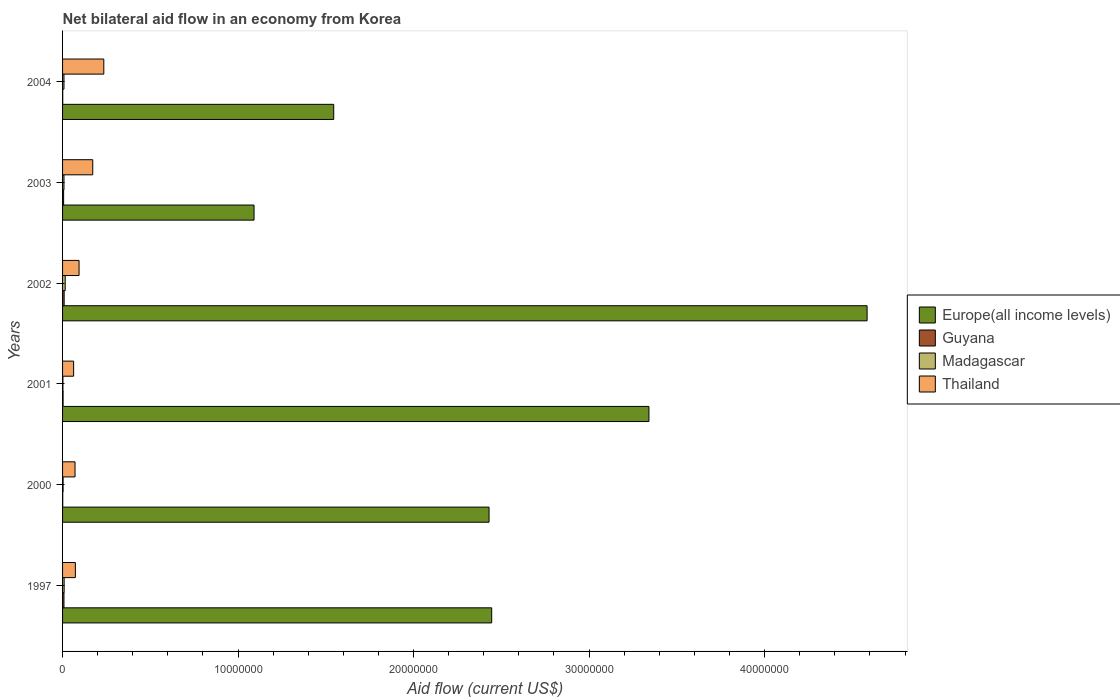How many bars are there on the 4th tick from the bottom?
Give a very brief answer. 4. Across all years, what is the maximum net bilateral aid flow in Europe(all income levels)?
Offer a terse response. 4.58e+07. Across all years, what is the minimum net bilateral aid flow in Guyana?
Your response must be concise. 10000. In which year was the net bilateral aid flow in Madagascar minimum?
Make the answer very short. 2001. What is the difference between the net bilateral aid flow in Guyana in 2003 and the net bilateral aid flow in Europe(all income levels) in 2002?
Your response must be concise. -4.58e+07. What is the average net bilateral aid flow in Madagascar per year?
Your answer should be compact. 7.50e+04. In the year 2000, what is the difference between the net bilateral aid flow in Guyana and net bilateral aid flow in Europe(all income levels)?
Make the answer very short. -2.43e+07. Is the net bilateral aid flow in Europe(all income levels) in 2000 less than that in 2004?
Make the answer very short. No. Is the difference between the net bilateral aid flow in Guyana in 2002 and 2003 greater than the difference between the net bilateral aid flow in Europe(all income levels) in 2002 and 2003?
Offer a very short reply. No. Is it the case that in every year, the sum of the net bilateral aid flow in Guyana and net bilateral aid flow in Thailand is greater than the sum of net bilateral aid flow in Madagascar and net bilateral aid flow in Europe(all income levels)?
Offer a very short reply. No. What does the 3rd bar from the top in 2004 represents?
Keep it short and to the point. Guyana. What does the 3rd bar from the bottom in 2003 represents?
Provide a succinct answer. Madagascar. Is it the case that in every year, the sum of the net bilateral aid flow in Madagascar and net bilateral aid flow in Thailand is greater than the net bilateral aid flow in Guyana?
Give a very brief answer. Yes. How many years are there in the graph?
Offer a very short reply. 6. What is the difference between two consecutive major ticks on the X-axis?
Give a very brief answer. 1.00e+07. Does the graph contain any zero values?
Offer a very short reply. No. Where does the legend appear in the graph?
Offer a very short reply. Center right. What is the title of the graph?
Offer a terse response. Net bilateral aid flow in an economy from Korea. What is the label or title of the X-axis?
Provide a succinct answer. Aid flow (current US$). What is the Aid flow (current US$) of Europe(all income levels) in 1997?
Provide a short and direct response. 2.44e+07. What is the Aid flow (current US$) in Guyana in 1997?
Your response must be concise. 8.00e+04. What is the Aid flow (current US$) of Thailand in 1997?
Keep it short and to the point. 7.30e+05. What is the Aid flow (current US$) in Europe(all income levels) in 2000?
Offer a very short reply. 2.43e+07. What is the Aid flow (current US$) of Guyana in 2000?
Offer a terse response. 10000. What is the Aid flow (current US$) in Madagascar in 2000?
Give a very brief answer. 3.00e+04. What is the Aid flow (current US$) of Thailand in 2000?
Your response must be concise. 7.10e+05. What is the Aid flow (current US$) in Europe(all income levels) in 2001?
Your answer should be very brief. 3.34e+07. What is the Aid flow (current US$) in Guyana in 2001?
Provide a succinct answer. 3.00e+04. What is the Aid flow (current US$) in Thailand in 2001?
Ensure brevity in your answer.  6.30e+05. What is the Aid flow (current US$) of Europe(all income levels) in 2002?
Your answer should be compact. 4.58e+07. What is the Aid flow (current US$) of Madagascar in 2002?
Your answer should be very brief. 1.50e+05. What is the Aid flow (current US$) of Thailand in 2002?
Your response must be concise. 9.40e+05. What is the Aid flow (current US$) of Europe(all income levels) in 2003?
Give a very brief answer. 1.09e+07. What is the Aid flow (current US$) in Thailand in 2003?
Make the answer very short. 1.72e+06. What is the Aid flow (current US$) of Europe(all income levels) in 2004?
Your response must be concise. 1.54e+07. What is the Aid flow (current US$) in Thailand in 2004?
Offer a terse response. 2.35e+06. Across all years, what is the maximum Aid flow (current US$) in Europe(all income levels)?
Offer a very short reply. 4.58e+07. Across all years, what is the maximum Aid flow (current US$) in Guyana?
Provide a succinct answer. 9.00e+04. Across all years, what is the maximum Aid flow (current US$) of Madagascar?
Offer a terse response. 1.50e+05. Across all years, what is the maximum Aid flow (current US$) of Thailand?
Provide a succinct answer. 2.35e+06. Across all years, what is the minimum Aid flow (current US$) in Europe(all income levels)?
Make the answer very short. 1.09e+07. Across all years, what is the minimum Aid flow (current US$) of Thailand?
Make the answer very short. 6.30e+05. What is the total Aid flow (current US$) in Europe(all income levels) in the graph?
Keep it short and to the point. 1.54e+08. What is the total Aid flow (current US$) in Madagascar in the graph?
Offer a very short reply. 4.50e+05. What is the total Aid flow (current US$) of Thailand in the graph?
Offer a terse response. 7.08e+06. What is the difference between the Aid flow (current US$) of Europe(all income levels) in 1997 and that in 2000?
Give a very brief answer. 1.50e+05. What is the difference between the Aid flow (current US$) of Europe(all income levels) in 1997 and that in 2001?
Ensure brevity in your answer.  -8.96e+06. What is the difference between the Aid flow (current US$) in Guyana in 1997 and that in 2001?
Give a very brief answer. 5.00e+04. What is the difference between the Aid flow (current US$) in Madagascar in 1997 and that in 2001?
Give a very brief answer. 7.00e+04. What is the difference between the Aid flow (current US$) in Thailand in 1997 and that in 2001?
Provide a succinct answer. 1.00e+05. What is the difference between the Aid flow (current US$) in Europe(all income levels) in 1997 and that in 2002?
Your answer should be very brief. -2.14e+07. What is the difference between the Aid flow (current US$) in Madagascar in 1997 and that in 2002?
Ensure brevity in your answer.  -6.00e+04. What is the difference between the Aid flow (current US$) in Thailand in 1997 and that in 2002?
Ensure brevity in your answer.  -2.10e+05. What is the difference between the Aid flow (current US$) in Europe(all income levels) in 1997 and that in 2003?
Your answer should be very brief. 1.35e+07. What is the difference between the Aid flow (current US$) in Guyana in 1997 and that in 2003?
Offer a very short reply. 2.00e+04. What is the difference between the Aid flow (current US$) in Madagascar in 1997 and that in 2003?
Your response must be concise. 10000. What is the difference between the Aid flow (current US$) in Thailand in 1997 and that in 2003?
Ensure brevity in your answer.  -9.90e+05. What is the difference between the Aid flow (current US$) of Europe(all income levels) in 1997 and that in 2004?
Your answer should be compact. 9.00e+06. What is the difference between the Aid flow (current US$) in Guyana in 1997 and that in 2004?
Keep it short and to the point. 7.00e+04. What is the difference between the Aid flow (current US$) of Madagascar in 1997 and that in 2004?
Make the answer very short. 10000. What is the difference between the Aid flow (current US$) in Thailand in 1997 and that in 2004?
Offer a terse response. -1.62e+06. What is the difference between the Aid flow (current US$) of Europe(all income levels) in 2000 and that in 2001?
Offer a very short reply. -9.11e+06. What is the difference between the Aid flow (current US$) in Guyana in 2000 and that in 2001?
Provide a succinct answer. -2.00e+04. What is the difference between the Aid flow (current US$) in Madagascar in 2000 and that in 2001?
Offer a terse response. 10000. What is the difference between the Aid flow (current US$) in Thailand in 2000 and that in 2001?
Offer a terse response. 8.00e+04. What is the difference between the Aid flow (current US$) of Europe(all income levels) in 2000 and that in 2002?
Offer a terse response. -2.15e+07. What is the difference between the Aid flow (current US$) in Guyana in 2000 and that in 2002?
Ensure brevity in your answer.  -8.00e+04. What is the difference between the Aid flow (current US$) of Thailand in 2000 and that in 2002?
Offer a very short reply. -2.30e+05. What is the difference between the Aid flow (current US$) of Europe(all income levels) in 2000 and that in 2003?
Your answer should be very brief. 1.34e+07. What is the difference between the Aid flow (current US$) in Thailand in 2000 and that in 2003?
Provide a succinct answer. -1.01e+06. What is the difference between the Aid flow (current US$) in Europe(all income levels) in 2000 and that in 2004?
Make the answer very short. 8.85e+06. What is the difference between the Aid flow (current US$) in Madagascar in 2000 and that in 2004?
Provide a succinct answer. -5.00e+04. What is the difference between the Aid flow (current US$) of Thailand in 2000 and that in 2004?
Provide a short and direct response. -1.64e+06. What is the difference between the Aid flow (current US$) of Europe(all income levels) in 2001 and that in 2002?
Ensure brevity in your answer.  -1.24e+07. What is the difference between the Aid flow (current US$) in Thailand in 2001 and that in 2002?
Offer a terse response. -3.10e+05. What is the difference between the Aid flow (current US$) of Europe(all income levels) in 2001 and that in 2003?
Your answer should be very brief. 2.25e+07. What is the difference between the Aid flow (current US$) of Thailand in 2001 and that in 2003?
Give a very brief answer. -1.09e+06. What is the difference between the Aid flow (current US$) of Europe(all income levels) in 2001 and that in 2004?
Offer a very short reply. 1.80e+07. What is the difference between the Aid flow (current US$) in Guyana in 2001 and that in 2004?
Your answer should be very brief. 2.00e+04. What is the difference between the Aid flow (current US$) in Thailand in 2001 and that in 2004?
Provide a short and direct response. -1.72e+06. What is the difference between the Aid flow (current US$) of Europe(all income levels) in 2002 and that in 2003?
Your answer should be compact. 3.49e+07. What is the difference between the Aid flow (current US$) in Madagascar in 2002 and that in 2003?
Your response must be concise. 7.00e+04. What is the difference between the Aid flow (current US$) of Thailand in 2002 and that in 2003?
Your response must be concise. -7.80e+05. What is the difference between the Aid flow (current US$) of Europe(all income levels) in 2002 and that in 2004?
Ensure brevity in your answer.  3.04e+07. What is the difference between the Aid flow (current US$) of Madagascar in 2002 and that in 2004?
Ensure brevity in your answer.  7.00e+04. What is the difference between the Aid flow (current US$) of Thailand in 2002 and that in 2004?
Keep it short and to the point. -1.41e+06. What is the difference between the Aid flow (current US$) of Europe(all income levels) in 2003 and that in 2004?
Provide a succinct answer. -4.54e+06. What is the difference between the Aid flow (current US$) in Guyana in 2003 and that in 2004?
Offer a terse response. 5.00e+04. What is the difference between the Aid flow (current US$) in Thailand in 2003 and that in 2004?
Provide a short and direct response. -6.30e+05. What is the difference between the Aid flow (current US$) of Europe(all income levels) in 1997 and the Aid flow (current US$) of Guyana in 2000?
Your answer should be compact. 2.44e+07. What is the difference between the Aid flow (current US$) in Europe(all income levels) in 1997 and the Aid flow (current US$) in Madagascar in 2000?
Your response must be concise. 2.44e+07. What is the difference between the Aid flow (current US$) in Europe(all income levels) in 1997 and the Aid flow (current US$) in Thailand in 2000?
Offer a terse response. 2.37e+07. What is the difference between the Aid flow (current US$) in Guyana in 1997 and the Aid flow (current US$) in Thailand in 2000?
Give a very brief answer. -6.30e+05. What is the difference between the Aid flow (current US$) in Madagascar in 1997 and the Aid flow (current US$) in Thailand in 2000?
Your answer should be very brief. -6.20e+05. What is the difference between the Aid flow (current US$) in Europe(all income levels) in 1997 and the Aid flow (current US$) in Guyana in 2001?
Provide a short and direct response. 2.44e+07. What is the difference between the Aid flow (current US$) in Europe(all income levels) in 1997 and the Aid flow (current US$) in Madagascar in 2001?
Keep it short and to the point. 2.44e+07. What is the difference between the Aid flow (current US$) of Europe(all income levels) in 1997 and the Aid flow (current US$) of Thailand in 2001?
Your answer should be compact. 2.38e+07. What is the difference between the Aid flow (current US$) of Guyana in 1997 and the Aid flow (current US$) of Thailand in 2001?
Provide a short and direct response. -5.50e+05. What is the difference between the Aid flow (current US$) in Madagascar in 1997 and the Aid flow (current US$) in Thailand in 2001?
Ensure brevity in your answer.  -5.40e+05. What is the difference between the Aid flow (current US$) of Europe(all income levels) in 1997 and the Aid flow (current US$) of Guyana in 2002?
Provide a succinct answer. 2.44e+07. What is the difference between the Aid flow (current US$) of Europe(all income levels) in 1997 and the Aid flow (current US$) of Madagascar in 2002?
Your response must be concise. 2.43e+07. What is the difference between the Aid flow (current US$) of Europe(all income levels) in 1997 and the Aid flow (current US$) of Thailand in 2002?
Your response must be concise. 2.35e+07. What is the difference between the Aid flow (current US$) in Guyana in 1997 and the Aid flow (current US$) in Madagascar in 2002?
Make the answer very short. -7.00e+04. What is the difference between the Aid flow (current US$) of Guyana in 1997 and the Aid flow (current US$) of Thailand in 2002?
Offer a terse response. -8.60e+05. What is the difference between the Aid flow (current US$) in Madagascar in 1997 and the Aid flow (current US$) in Thailand in 2002?
Offer a terse response. -8.50e+05. What is the difference between the Aid flow (current US$) in Europe(all income levels) in 1997 and the Aid flow (current US$) in Guyana in 2003?
Your answer should be compact. 2.44e+07. What is the difference between the Aid flow (current US$) in Europe(all income levels) in 1997 and the Aid flow (current US$) in Madagascar in 2003?
Make the answer very short. 2.44e+07. What is the difference between the Aid flow (current US$) in Europe(all income levels) in 1997 and the Aid flow (current US$) in Thailand in 2003?
Provide a short and direct response. 2.27e+07. What is the difference between the Aid flow (current US$) of Guyana in 1997 and the Aid flow (current US$) of Thailand in 2003?
Keep it short and to the point. -1.64e+06. What is the difference between the Aid flow (current US$) of Madagascar in 1997 and the Aid flow (current US$) of Thailand in 2003?
Provide a short and direct response. -1.63e+06. What is the difference between the Aid flow (current US$) in Europe(all income levels) in 1997 and the Aid flow (current US$) in Guyana in 2004?
Your response must be concise. 2.44e+07. What is the difference between the Aid flow (current US$) in Europe(all income levels) in 1997 and the Aid flow (current US$) in Madagascar in 2004?
Provide a succinct answer. 2.44e+07. What is the difference between the Aid flow (current US$) in Europe(all income levels) in 1997 and the Aid flow (current US$) in Thailand in 2004?
Offer a very short reply. 2.21e+07. What is the difference between the Aid flow (current US$) in Guyana in 1997 and the Aid flow (current US$) in Thailand in 2004?
Keep it short and to the point. -2.27e+06. What is the difference between the Aid flow (current US$) of Madagascar in 1997 and the Aid flow (current US$) of Thailand in 2004?
Your answer should be very brief. -2.26e+06. What is the difference between the Aid flow (current US$) in Europe(all income levels) in 2000 and the Aid flow (current US$) in Guyana in 2001?
Give a very brief answer. 2.43e+07. What is the difference between the Aid flow (current US$) of Europe(all income levels) in 2000 and the Aid flow (current US$) of Madagascar in 2001?
Offer a very short reply. 2.43e+07. What is the difference between the Aid flow (current US$) in Europe(all income levels) in 2000 and the Aid flow (current US$) in Thailand in 2001?
Your answer should be compact. 2.37e+07. What is the difference between the Aid flow (current US$) of Guyana in 2000 and the Aid flow (current US$) of Madagascar in 2001?
Ensure brevity in your answer.  -10000. What is the difference between the Aid flow (current US$) of Guyana in 2000 and the Aid flow (current US$) of Thailand in 2001?
Keep it short and to the point. -6.20e+05. What is the difference between the Aid flow (current US$) of Madagascar in 2000 and the Aid flow (current US$) of Thailand in 2001?
Your answer should be compact. -6.00e+05. What is the difference between the Aid flow (current US$) of Europe(all income levels) in 2000 and the Aid flow (current US$) of Guyana in 2002?
Give a very brief answer. 2.42e+07. What is the difference between the Aid flow (current US$) in Europe(all income levels) in 2000 and the Aid flow (current US$) in Madagascar in 2002?
Your answer should be very brief. 2.42e+07. What is the difference between the Aid flow (current US$) of Europe(all income levels) in 2000 and the Aid flow (current US$) of Thailand in 2002?
Give a very brief answer. 2.34e+07. What is the difference between the Aid flow (current US$) in Guyana in 2000 and the Aid flow (current US$) in Madagascar in 2002?
Give a very brief answer. -1.40e+05. What is the difference between the Aid flow (current US$) of Guyana in 2000 and the Aid flow (current US$) of Thailand in 2002?
Make the answer very short. -9.30e+05. What is the difference between the Aid flow (current US$) in Madagascar in 2000 and the Aid flow (current US$) in Thailand in 2002?
Ensure brevity in your answer.  -9.10e+05. What is the difference between the Aid flow (current US$) in Europe(all income levels) in 2000 and the Aid flow (current US$) in Guyana in 2003?
Your response must be concise. 2.42e+07. What is the difference between the Aid flow (current US$) in Europe(all income levels) in 2000 and the Aid flow (current US$) in Madagascar in 2003?
Your answer should be compact. 2.42e+07. What is the difference between the Aid flow (current US$) of Europe(all income levels) in 2000 and the Aid flow (current US$) of Thailand in 2003?
Give a very brief answer. 2.26e+07. What is the difference between the Aid flow (current US$) in Guyana in 2000 and the Aid flow (current US$) in Thailand in 2003?
Provide a succinct answer. -1.71e+06. What is the difference between the Aid flow (current US$) in Madagascar in 2000 and the Aid flow (current US$) in Thailand in 2003?
Provide a succinct answer. -1.69e+06. What is the difference between the Aid flow (current US$) of Europe(all income levels) in 2000 and the Aid flow (current US$) of Guyana in 2004?
Offer a terse response. 2.43e+07. What is the difference between the Aid flow (current US$) of Europe(all income levels) in 2000 and the Aid flow (current US$) of Madagascar in 2004?
Your response must be concise. 2.42e+07. What is the difference between the Aid flow (current US$) of Europe(all income levels) in 2000 and the Aid flow (current US$) of Thailand in 2004?
Provide a succinct answer. 2.20e+07. What is the difference between the Aid flow (current US$) in Guyana in 2000 and the Aid flow (current US$) in Madagascar in 2004?
Your response must be concise. -7.00e+04. What is the difference between the Aid flow (current US$) in Guyana in 2000 and the Aid flow (current US$) in Thailand in 2004?
Your answer should be compact. -2.34e+06. What is the difference between the Aid flow (current US$) in Madagascar in 2000 and the Aid flow (current US$) in Thailand in 2004?
Make the answer very short. -2.32e+06. What is the difference between the Aid flow (current US$) in Europe(all income levels) in 2001 and the Aid flow (current US$) in Guyana in 2002?
Provide a succinct answer. 3.33e+07. What is the difference between the Aid flow (current US$) in Europe(all income levels) in 2001 and the Aid flow (current US$) in Madagascar in 2002?
Provide a short and direct response. 3.33e+07. What is the difference between the Aid flow (current US$) of Europe(all income levels) in 2001 and the Aid flow (current US$) of Thailand in 2002?
Provide a short and direct response. 3.25e+07. What is the difference between the Aid flow (current US$) of Guyana in 2001 and the Aid flow (current US$) of Madagascar in 2002?
Offer a very short reply. -1.20e+05. What is the difference between the Aid flow (current US$) of Guyana in 2001 and the Aid flow (current US$) of Thailand in 2002?
Your response must be concise. -9.10e+05. What is the difference between the Aid flow (current US$) in Madagascar in 2001 and the Aid flow (current US$) in Thailand in 2002?
Your answer should be compact. -9.20e+05. What is the difference between the Aid flow (current US$) of Europe(all income levels) in 2001 and the Aid flow (current US$) of Guyana in 2003?
Provide a short and direct response. 3.34e+07. What is the difference between the Aid flow (current US$) in Europe(all income levels) in 2001 and the Aid flow (current US$) in Madagascar in 2003?
Keep it short and to the point. 3.33e+07. What is the difference between the Aid flow (current US$) of Europe(all income levels) in 2001 and the Aid flow (current US$) of Thailand in 2003?
Offer a terse response. 3.17e+07. What is the difference between the Aid flow (current US$) in Guyana in 2001 and the Aid flow (current US$) in Madagascar in 2003?
Offer a very short reply. -5.00e+04. What is the difference between the Aid flow (current US$) in Guyana in 2001 and the Aid flow (current US$) in Thailand in 2003?
Provide a short and direct response. -1.69e+06. What is the difference between the Aid flow (current US$) of Madagascar in 2001 and the Aid flow (current US$) of Thailand in 2003?
Give a very brief answer. -1.70e+06. What is the difference between the Aid flow (current US$) in Europe(all income levels) in 2001 and the Aid flow (current US$) in Guyana in 2004?
Offer a very short reply. 3.34e+07. What is the difference between the Aid flow (current US$) in Europe(all income levels) in 2001 and the Aid flow (current US$) in Madagascar in 2004?
Your answer should be compact. 3.33e+07. What is the difference between the Aid flow (current US$) of Europe(all income levels) in 2001 and the Aid flow (current US$) of Thailand in 2004?
Provide a short and direct response. 3.11e+07. What is the difference between the Aid flow (current US$) of Guyana in 2001 and the Aid flow (current US$) of Thailand in 2004?
Offer a very short reply. -2.32e+06. What is the difference between the Aid flow (current US$) of Madagascar in 2001 and the Aid flow (current US$) of Thailand in 2004?
Make the answer very short. -2.33e+06. What is the difference between the Aid flow (current US$) in Europe(all income levels) in 2002 and the Aid flow (current US$) in Guyana in 2003?
Give a very brief answer. 4.58e+07. What is the difference between the Aid flow (current US$) of Europe(all income levels) in 2002 and the Aid flow (current US$) of Madagascar in 2003?
Make the answer very short. 4.58e+07. What is the difference between the Aid flow (current US$) in Europe(all income levels) in 2002 and the Aid flow (current US$) in Thailand in 2003?
Give a very brief answer. 4.41e+07. What is the difference between the Aid flow (current US$) of Guyana in 2002 and the Aid flow (current US$) of Thailand in 2003?
Keep it short and to the point. -1.63e+06. What is the difference between the Aid flow (current US$) in Madagascar in 2002 and the Aid flow (current US$) in Thailand in 2003?
Your answer should be compact. -1.57e+06. What is the difference between the Aid flow (current US$) in Europe(all income levels) in 2002 and the Aid flow (current US$) in Guyana in 2004?
Ensure brevity in your answer.  4.58e+07. What is the difference between the Aid flow (current US$) in Europe(all income levels) in 2002 and the Aid flow (current US$) in Madagascar in 2004?
Your response must be concise. 4.58e+07. What is the difference between the Aid flow (current US$) of Europe(all income levels) in 2002 and the Aid flow (current US$) of Thailand in 2004?
Your answer should be very brief. 4.35e+07. What is the difference between the Aid flow (current US$) of Guyana in 2002 and the Aid flow (current US$) of Madagascar in 2004?
Provide a short and direct response. 10000. What is the difference between the Aid flow (current US$) of Guyana in 2002 and the Aid flow (current US$) of Thailand in 2004?
Offer a very short reply. -2.26e+06. What is the difference between the Aid flow (current US$) in Madagascar in 2002 and the Aid flow (current US$) in Thailand in 2004?
Offer a terse response. -2.20e+06. What is the difference between the Aid flow (current US$) of Europe(all income levels) in 2003 and the Aid flow (current US$) of Guyana in 2004?
Provide a short and direct response. 1.09e+07. What is the difference between the Aid flow (current US$) in Europe(all income levels) in 2003 and the Aid flow (current US$) in Madagascar in 2004?
Your response must be concise. 1.08e+07. What is the difference between the Aid flow (current US$) in Europe(all income levels) in 2003 and the Aid flow (current US$) in Thailand in 2004?
Keep it short and to the point. 8.56e+06. What is the difference between the Aid flow (current US$) in Guyana in 2003 and the Aid flow (current US$) in Madagascar in 2004?
Your response must be concise. -2.00e+04. What is the difference between the Aid flow (current US$) in Guyana in 2003 and the Aid flow (current US$) in Thailand in 2004?
Offer a very short reply. -2.29e+06. What is the difference between the Aid flow (current US$) of Madagascar in 2003 and the Aid flow (current US$) of Thailand in 2004?
Offer a terse response. -2.27e+06. What is the average Aid flow (current US$) in Europe(all income levels) per year?
Offer a terse response. 2.57e+07. What is the average Aid flow (current US$) of Guyana per year?
Offer a terse response. 4.67e+04. What is the average Aid flow (current US$) in Madagascar per year?
Make the answer very short. 7.50e+04. What is the average Aid flow (current US$) of Thailand per year?
Your answer should be compact. 1.18e+06. In the year 1997, what is the difference between the Aid flow (current US$) of Europe(all income levels) and Aid flow (current US$) of Guyana?
Your answer should be compact. 2.44e+07. In the year 1997, what is the difference between the Aid flow (current US$) in Europe(all income levels) and Aid flow (current US$) in Madagascar?
Offer a very short reply. 2.44e+07. In the year 1997, what is the difference between the Aid flow (current US$) in Europe(all income levels) and Aid flow (current US$) in Thailand?
Offer a very short reply. 2.37e+07. In the year 1997, what is the difference between the Aid flow (current US$) of Guyana and Aid flow (current US$) of Madagascar?
Make the answer very short. -10000. In the year 1997, what is the difference between the Aid flow (current US$) in Guyana and Aid flow (current US$) in Thailand?
Offer a very short reply. -6.50e+05. In the year 1997, what is the difference between the Aid flow (current US$) in Madagascar and Aid flow (current US$) in Thailand?
Give a very brief answer. -6.40e+05. In the year 2000, what is the difference between the Aid flow (current US$) of Europe(all income levels) and Aid flow (current US$) of Guyana?
Give a very brief answer. 2.43e+07. In the year 2000, what is the difference between the Aid flow (current US$) in Europe(all income levels) and Aid flow (current US$) in Madagascar?
Offer a very short reply. 2.43e+07. In the year 2000, what is the difference between the Aid flow (current US$) in Europe(all income levels) and Aid flow (current US$) in Thailand?
Offer a terse response. 2.36e+07. In the year 2000, what is the difference between the Aid flow (current US$) in Guyana and Aid flow (current US$) in Madagascar?
Make the answer very short. -2.00e+04. In the year 2000, what is the difference between the Aid flow (current US$) in Guyana and Aid flow (current US$) in Thailand?
Make the answer very short. -7.00e+05. In the year 2000, what is the difference between the Aid flow (current US$) in Madagascar and Aid flow (current US$) in Thailand?
Your answer should be compact. -6.80e+05. In the year 2001, what is the difference between the Aid flow (current US$) in Europe(all income levels) and Aid flow (current US$) in Guyana?
Keep it short and to the point. 3.34e+07. In the year 2001, what is the difference between the Aid flow (current US$) of Europe(all income levels) and Aid flow (current US$) of Madagascar?
Provide a short and direct response. 3.34e+07. In the year 2001, what is the difference between the Aid flow (current US$) of Europe(all income levels) and Aid flow (current US$) of Thailand?
Provide a short and direct response. 3.28e+07. In the year 2001, what is the difference between the Aid flow (current US$) of Guyana and Aid flow (current US$) of Thailand?
Make the answer very short. -6.00e+05. In the year 2001, what is the difference between the Aid flow (current US$) of Madagascar and Aid flow (current US$) of Thailand?
Offer a very short reply. -6.10e+05. In the year 2002, what is the difference between the Aid flow (current US$) of Europe(all income levels) and Aid flow (current US$) of Guyana?
Provide a short and direct response. 4.58e+07. In the year 2002, what is the difference between the Aid flow (current US$) of Europe(all income levels) and Aid flow (current US$) of Madagascar?
Your answer should be very brief. 4.57e+07. In the year 2002, what is the difference between the Aid flow (current US$) of Europe(all income levels) and Aid flow (current US$) of Thailand?
Your answer should be compact. 4.49e+07. In the year 2002, what is the difference between the Aid flow (current US$) in Guyana and Aid flow (current US$) in Madagascar?
Make the answer very short. -6.00e+04. In the year 2002, what is the difference between the Aid flow (current US$) of Guyana and Aid flow (current US$) of Thailand?
Keep it short and to the point. -8.50e+05. In the year 2002, what is the difference between the Aid flow (current US$) of Madagascar and Aid flow (current US$) of Thailand?
Offer a terse response. -7.90e+05. In the year 2003, what is the difference between the Aid flow (current US$) in Europe(all income levels) and Aid flow (current US$) in Guyana?
Ensure brevity in your answer.  1.08e+07. In the year 2003, what is the difference between the Aid flow (current US$) of Europe(all income levels) and Aid flow (current US$) of Madagascar?
Ensure brevity in your answer.  1.08e+07. In the year 2003, what is the difference between the Aid flow (current US$) in Europe(all income levels) and Aid flow (current US$) in Thailand?
Provide a short and direct response. 9.19e+06. In the year 2003, what is the difference between the Aid flow (current US$) in Guyana and Aid flow (current US$) in Thailand?
Your answer should be compact. -1.66e+06. In the year 2003, what is the difference between the Aid flow (current US$) in Madagascar and Aid flow (current US$) in Thailand?
Your response must be concise. -1.64e+06. In the year 2004, what is the difference between the Aid flow (current US$) of Europe(all income levels) and Aid flow (current US$) of Guyana?
Offer a terse response. 1.54e+07. In the year 2004, what is the difference between the Aid flow (current US$) in Europe(all income levels) and Aid flow (current US$) in Madagascar?
Provide a short and direct response. 1.54e+07. In the year 2004, what is the difference between the Aid flow (current US$) of Europe(all income levels) and Aid flow (current US$) of Thailand?
Your answer should be compact. 1.31e+07. In the year 2004, what is the difference between the Aid flow (current US$) in Guyana and Aid flow (current US$) in Madagascar?
Ensure brevity in your answer.  -7.00e+04. In the year 2004, what is the difference between the Aid flow (current US$) in Guyana and Aid flow (current US$) in Thailand?
Provide a short and direct response. -2.34e+06. In the year 2004, what is the difference between the Aid flow (current US$) of Madagascar and Aid flow (current US$) of Thailand?
Ensure brevity in your answer.  -2.27e+06. What is the ratio of the Aid flow (current US$) in Europe(all income levels) in 1997 to that in 2000?
Your response must be concise. 1.01. What is the ratio of the Aid flow (current US$) of Guyana in 1997 to that in 2000?
Offer a very short reply. 8. What is the ratio of the Aid flow (current US$) of Madagascar in 1997 to that in 2000?
Your answer should be very brief. 3. What is the ratio of the Aid flow (current US$) in Thailand in 1997 to that in 2000?
Provide a short and direct response. 1.03. What is the ratio of the Aid flow (current US$) of Europe(all income levels) in 1997 to that in 2001?
Your answer should be very brief. 0.73. What is the ratio of the Aid flow (current US$) of Guyana in 1997 to that in 2001?
Your answer should be compact. 2.67. What is the ratio of the Aid flow (current US$) of Madagascar in 1997 to that in 2001?
Keep it short and to the point. 4.5. What is the ratio of the Aid flow (current US$) of Thailand in 1997 to that in 2001?
Ensure brevity in your answer.  1.16. What is the ratio of the Aid flow (current US$) in Europe(all income levels) in 1997 to that in 2002?
Offer a terse response. 0.53. What is the ratio of the Aid flow (current US$) of Guyana in 1997 to that in 2002?
Keep it short and to the point. 0.89. What is the ratio of the Aid flow (current US$) in Thailand in 1997 to that in 2002?
Provide a short and direct response. 0.78. What is the ratio of the Aid flow (current US$) in Europe(all income levels) in 1997 to that in 2003?
Offer a terse response. 2.24. What is the ratio of the Aid flow (current US$) in Madagascar in 1997 to that in 2003?
Give a very brief answer. 1.12. What is the ratio of the Aid flow (current US$) of Thailand in 1997 to that in 2003?
Your answer should be very brief. 0.42. What is the ratio of the Aid flow (current US$) in Europe(all income levels) in 1997 to that in 2004?
Your response must be concise. 1.58. What is the ratio of the Aid flow (current US$) in Thailand in 1997 to that in 2004?
Provide a succinct answer. 0.31. What is the ratio of the Aid flow (current US$) in Europe(all income levels) in 2000 to that in 2001?
Give a very brief answer. 0.73. What is the ratio of the Aid flow (current US$) in Thailand in 2000 to that in 2001?
Give a very brief answer. 1.13. What is the ratio of the Aid flow (current US$) of Europe(all income levels) in 2000 to that in 2002?
Provide a succinct answer. 0.53. What is the ratio of the Aid flow (current US$) in Guyana in 2000 to that in 2002?
Your answer should be very brief. 0.11. What is the ratio of the Aid flow (current US$) in Madagascar in 2000 to that in 2002?
Provide a short and direct response. 0.2. What is the ratio of the Aid flow (current US$) in Thailand in 2000 to that in 2002?
Offer a terse response. 0.76. What is the ratio of the Aid flow (current US$) in Europe(all income levels) in 2000 to that in 2003?
Give a very brief answer. 2.23. What is the ratio of the Aid flow (current US$) of Madagascar in 2000 to that in 2003?
Your answer should be very brief. 0.38. What is the ratio of the Aid flow (current US$) in Thailand in 2000 to that in 2003?
Make the answer very short. 0.41. What is the ratio of the Aid flow (current US$) in Europe(all income levels) in 2000 to that in 2004?
Your answer should be compact. 1.57. What is the ratio of the Aid flow (current US$) of Thailand in 2000 to that in 2004?
Provide a succinct answer. 0.3. What is the ratio of the Aid flow (current US$) of Europe(all income levels) in 2001 to that in 2002?
Your answer should be very brief. 0.73. What is the ratio of the Aid flow (current US$) of Guyana in 2001 to that in 2002?
Your response must be concise. 0.33. What is the ratio of the Aid flow (current US$) of Madagascar in 2001 to that in 2002?
Give a very brief answer. 0.13. What is the ratio of the Aid flow (current US$) of Thailand in 2001 to that in 2002?
Make the answer very short. 0.67. What is the ratio of the Aid flow (current US$) of Europe(all income levels) in 2001 to that in 2003?
Provide a succinct answer. 3.06. What is the ratio of the Aid flow (current US$) in Thailand in 2001 to that in 2003?
Ensure brevity in your answer.  0.37. What is the ratio of the Aid flow (current US$) of Europe(all income levels) in 2001 to that in 2004?
Ensure brevity in your answer.  2.16. What is the ratio of the Aid flow (current US$) in Guyana in 2001 to that in 2004?
Give a very brief answer. 3. What is the ratio of the Aid flow (current US$) in Thailand in 2001 to that in 2004?
Ensure brevity in your answer.  0.27. What is the ratio of the Aid flow (current US$) of Europe(all income levels) in 2002 to that in 2003?
Your answer should be very brief. 4.2. What is the ratio of the Aid flow (current US$) of Guyana in 2002 to that in 2003?
Provide a succinct answer. 1.5. What is the ratio of the Aid flow (current US$) in Madagascar in 2002 to that in 2003?
Keep it short and to the point. 1.88. What is the ratio of the Aid flow (current US$) in Thailand in 2002 to that in 2003?
Provide a short and direct response. 0.55. What is the ratio of the Aid flow (current US$) of Europe(all income levels) in 2002 to that in 2004?
Your answer should be compact. 2.97. What is the ratio of the Aid flow (current US$) of Madagascar in 2002 to that in 2004?
Provide a succinct answer. 1.88. What is the ratio of the Aid flow (current US$) in Europe(all income levels) in 2003 to that in 2004?
Keep it short and to the point. 0.71. What is the ratio of the Aid flow (current US$) in Guyana in 2003 to that in 2004?
Keep it short and to the point. 6. What is the ratio of the Aid flow (current US$) of Madagascar in 2003 to that in 2004?
Ensure brevity in your answer.  1. What is the ratio of the Aid flow (current US$) of Thailand in 2003 to that in 2004?
Ensure brevity in your answer.  0.73. What is the difference between the highest and the second highest Aid flow (current US$) in Europe(all income levels)?
Keep it short and to the point. 1.24e+07. What is the difference between the highest and the second highest Aid flow (current US$) of Guyana?
Give a very brief answer. 10000. What is the difference between the highest and the second highest Aid flow (current US$) of Madagascar?
Keep it short and to the point. 6.00e+04. What is the difference between the highest and the second highest Aid flow (current US$) of Thailand?
Give a very brief answer. 6.30e+05. What is the difference between the highest and the lowest Aid flow (current US$) in Europe(all income levels)?
Give a very brief answer. 3.49e+07. What is the difference between the highest and the lowest Aid flow (current US$) in Madagascar?
Offer a terse response. 1.30e+05. What is the difference between the highest and the lowest Aid flow (current US$) of Thailand?
Offer a terse response. 1.72e+06. 